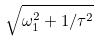<formula> <loc_0><loc_0><loc_500><loc_500>\sqrt { \omega _ { 1 } ^ { 2 } + 1 / \tau ^ { 2 } }</formula> 